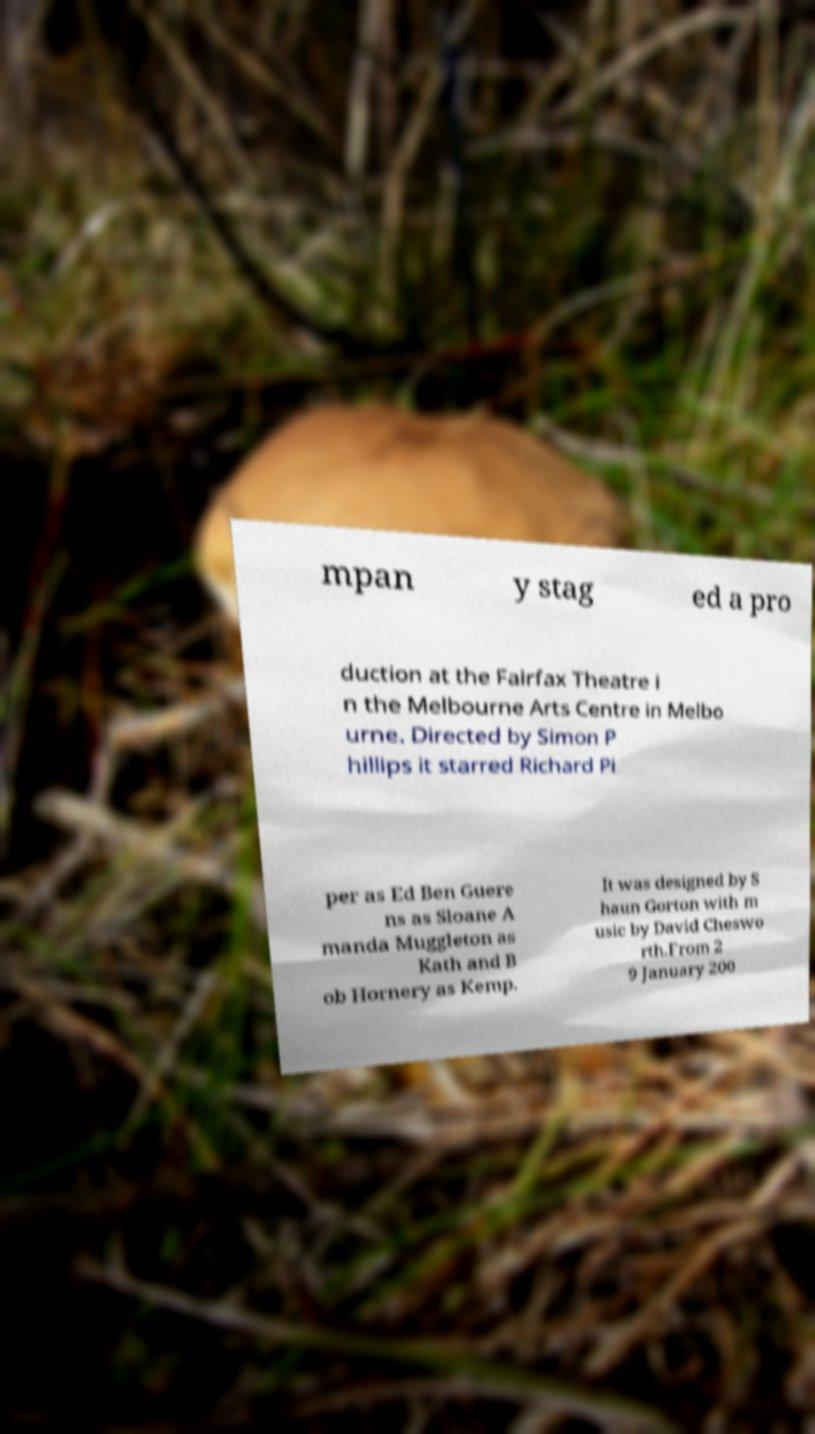Please identify and transcribe the text found in this image. mpan y stag ed a pro duction at the Fairfax Theatre i n the Melbourne Arts Centre in Melbo urne. Directed by Simon P hillips it starred Richard Pi per as Ed Ben Guere ns as Sloane A manda Muggleton as Kath and B ob Hornery as Kemp. It was designed by S haun Gorton with m usic by David Cheswo rth.From 2 9 January 200 